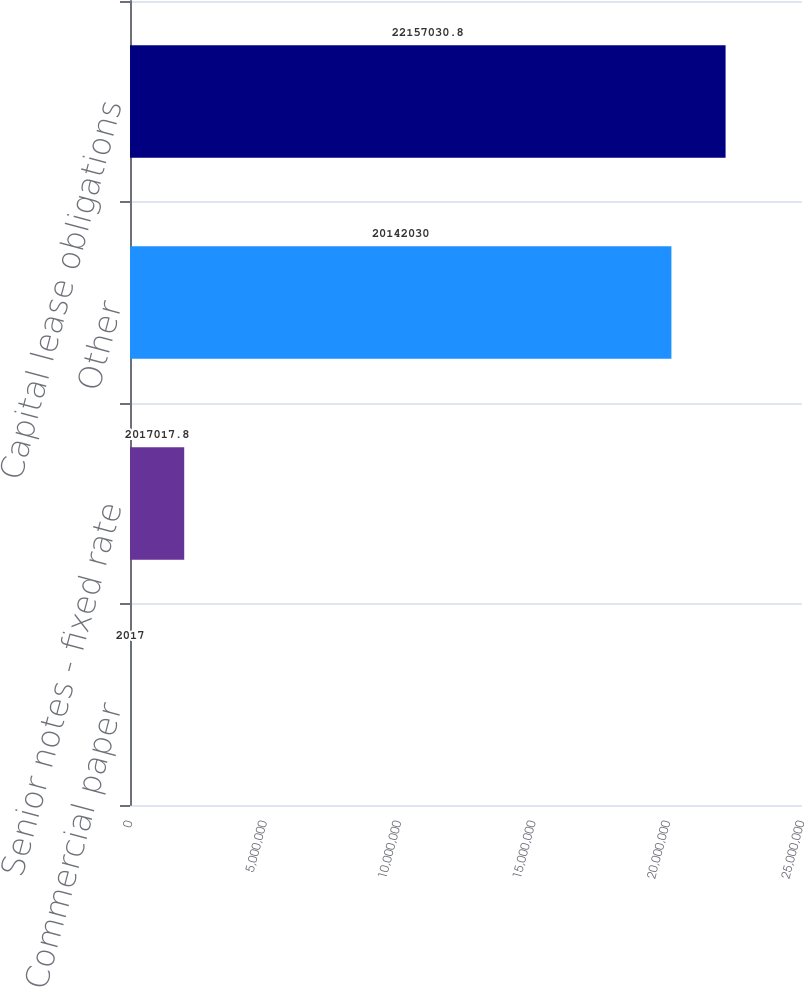<chart> <loc_0><loc_0><loc_500><loc_500><bar_chart><fcel>Commercial paper<fcel>Senior notes - fixed rate<fcel>Other<fcel>Capital lease obligations<nl><fcel>2017<fcel>2.01702e+06<fcel>2.0142e+07<fcel>2.2157e+07<nl></chart> 